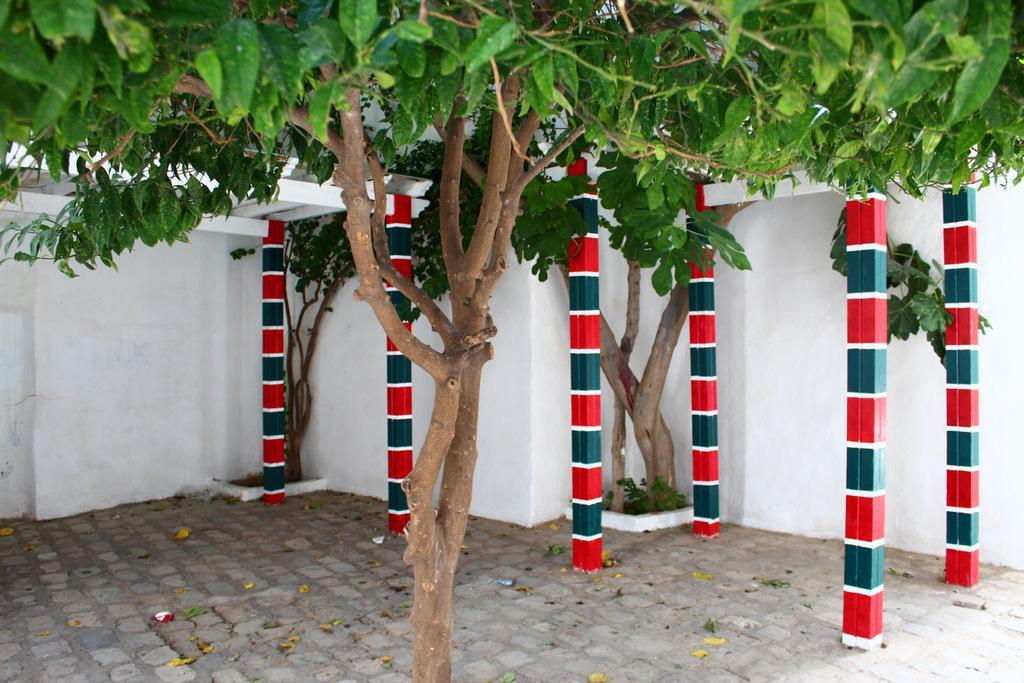In one or two sentences, can you explain what this image depicts? This picture is clicked outside. In the foreground we can see the tree. In the center we can see the wall, pillars, trees, plants and some other items. 